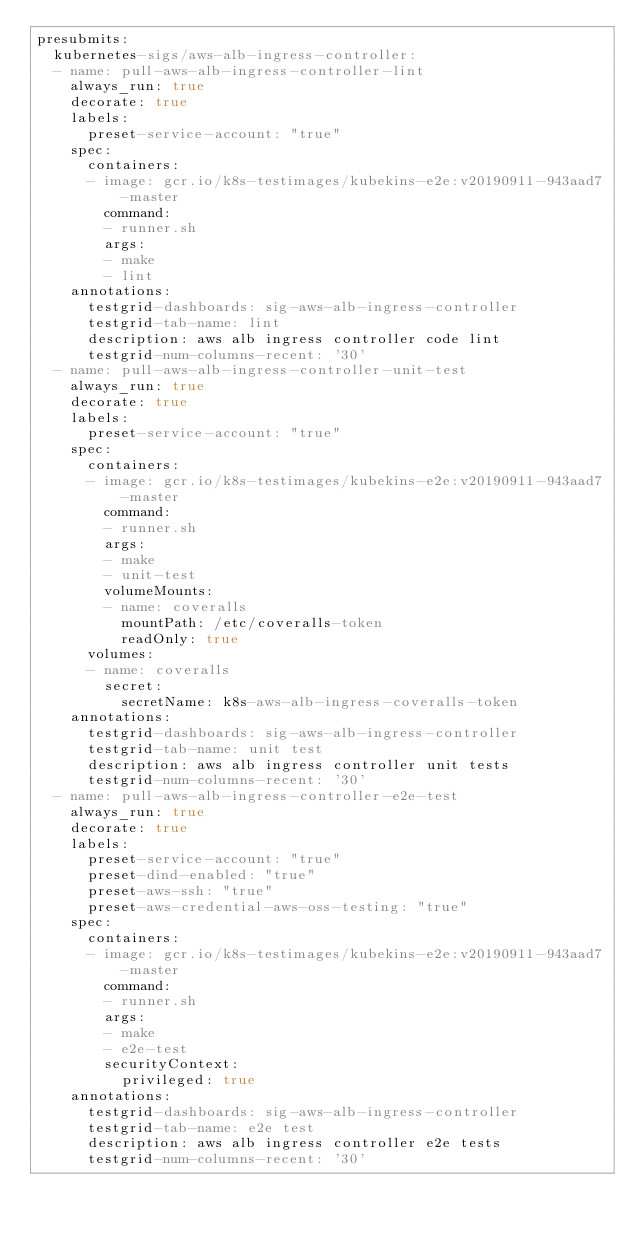Convert code to text. <code><loc_0><loc_0><loc_500><loc_500><_YAML_>presubmits:
  kubernetes-sigs/aws-alb-ingress-controller:
  - name: pull-aws-alb-ingress-controller-lint
    always_run: true
    decorate: true
    labels:
      preset-service-account: "true"
    spec:
      containers:
      - image: gcr.io/k8s-testimages/kubekins-e2e:v20190911-943aad7-master
        command:
        - runner.sh
        args:
        - make
        - lint
    annotations:
      testgrid-dashboards: sig-aws-alb-ingress-controller
      testgrid-tab-name: lint
      description: aws alb ingress controller code lint
      testgrid-num-columns-recent: '30'
  - name: pull-aws-alb-ingress-controller-unit-test
    always_run: true
    decorate: true
    labels:
      preset-service-account: "true"
    spec:
      containers:
      - image: gcr.io/k8s-testimages/kubekins-e2e:v20190911-943aad7-master
        command:
        - runner.sh
        args:
        - make
        - unit-test
        volumeMounts:
        - name: coveralls
          mountPath: /etc/coveralls-token
          readOnly: true
      volumes:
      - name: coveralls
        secret:
          secretName: k8s-aws-alb-ingress-coveralls-token
    annotations:
      testgrid-dashboards: sig-aws-alb-ingress-controller
      testgrid-tab-name: unit test
      description: aws alb ingress controller unit tests
      testgrid-num-columns-recent: '30'
  - name: pull-aws-alb-ingress-controller-e2e-test
    always_run: true
    decorate: true
    labels:
      preset-service-account: "true"
      preset-dind-enabled: "true"
      preset-aws-ssh: "true"
      preset-aws-credential-aws-oss-testing: "true"
    spec:
      containers:
      - image: gcr.io/k8s-testimages/kubekins-e2e:v20190911-943aad7-master
        command:
        - runner.sh
        args:
        - make
        - e2e-test
        securityContext:
          privileged: true
    annotations:
      testgrid-dashboards: sig-aws-alb-ingress-controller
      testgrid-tab-name: e2e test
      description: aws alb ingress controller e2e tests
      testgrid-num-columns-recent: '30'
</code> 